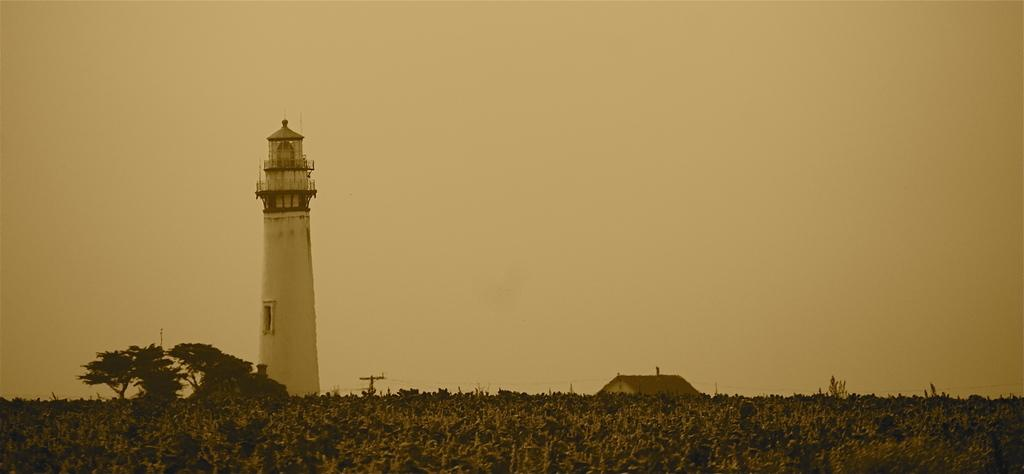What type of view is shown in the image? The image is an outside view. What can be seen at the bottom of the image? There are many plants and trees at the bottom of the image. What structures are visible in the background of the image? There is a tower and a house in the background of the image. What is visible at the top of the image? The sky is visible at the top of the image. What channel is the woman watching in the image? There is no woman or television present in the image, so it is not possible to determine what channel she might be watching. 